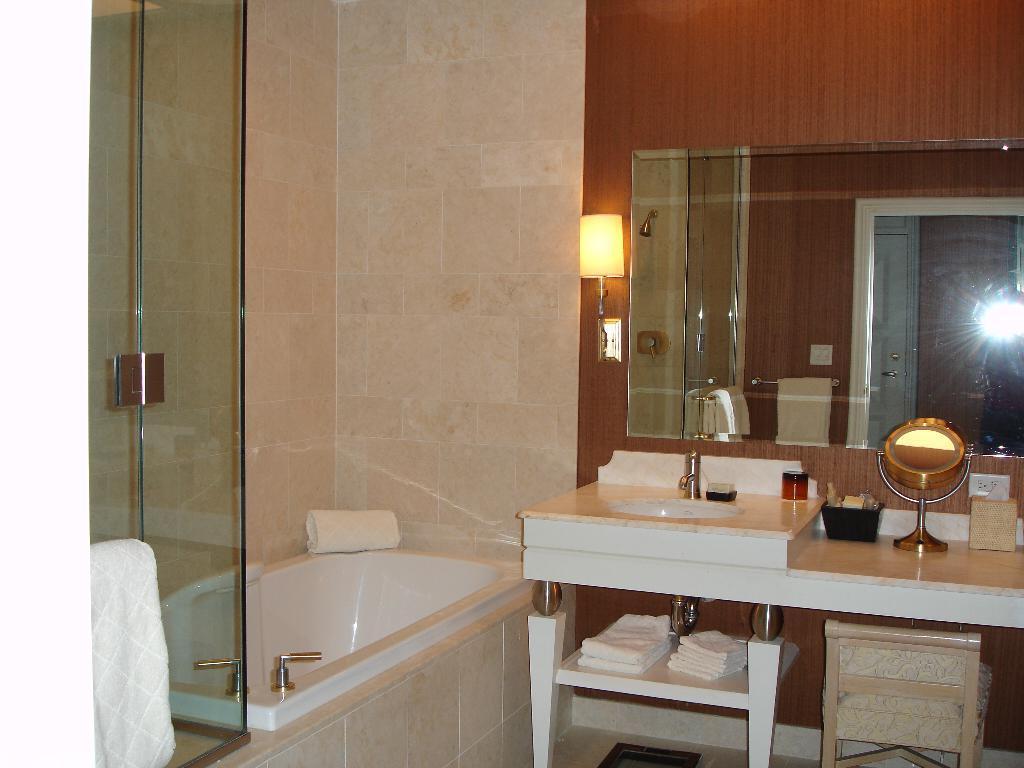Could you give a brief overview of what you see in this image? This image is inside the bathroom where we can see glass doors, towels, bathtub, table upon which we can see basin, mirror and bottles placed, here we can see the chair, lamp, socket, mirror through which we can see towel stand, door and the wooden wall in the background. 